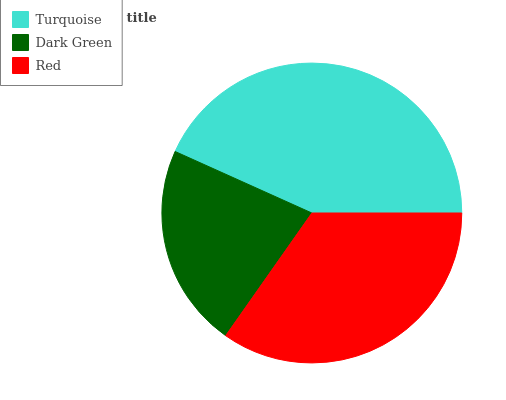Is Dark Green the minimum?
Answer yes or no. Yes. Is Turquoise the maximum?
Answer yes or no. Yes. Is Red the minimum?
Answer yes or no. No. Is Red the maximum?
Answer yes or no. No. Is Red greater than Dark Green?
Answer yes or no. Yes. Is Dark Green less than Red?
Answer yes or no. Yes. Is Dark Green greater than Red?
Answer yes or no. No. Is Red less than Dark Green?
Answer yes or no. No. Is Red the high median?
Answer yes or no. Yes. Is Red the low median?
Answer yes or no. Yes. Is Dark Green the high median?
Answer yes or no. No. Is Dark Green the low median?
Answer yes or no. No. 